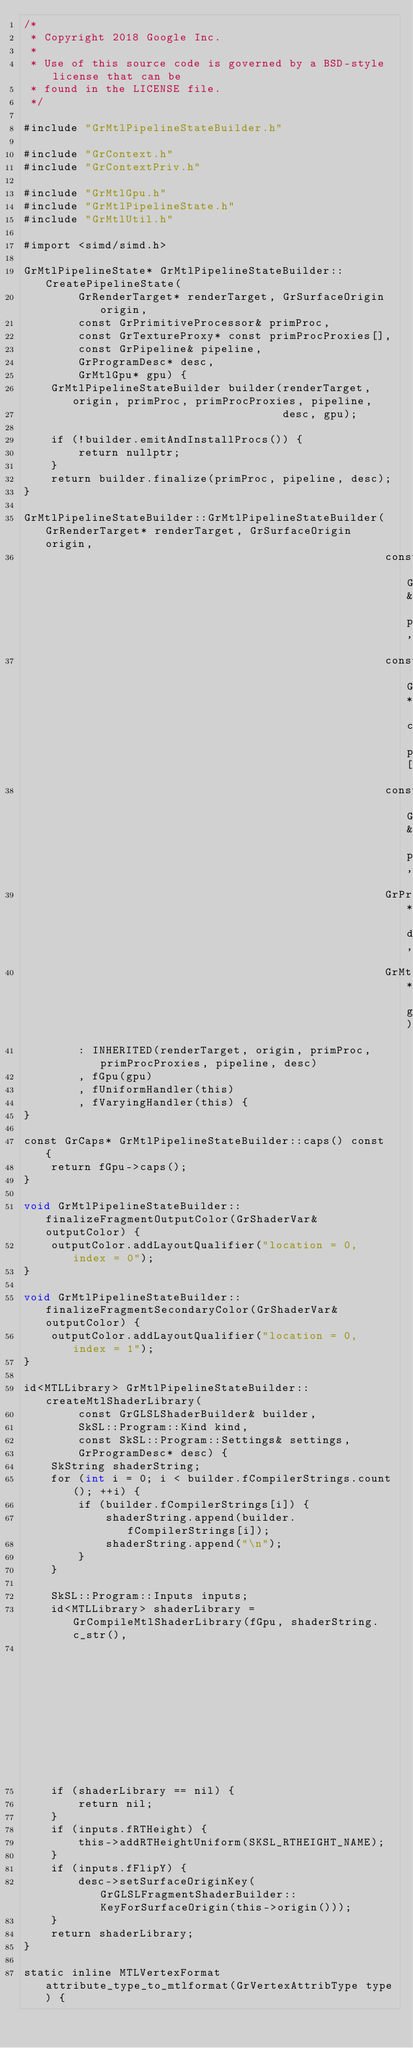Convert code to text. <code><loc_0><loc_0><loc_500><loc_500><_ObjectiveC_>/*
 * Copyright 2018 Google Inc.
 *
 * Use of this source code is governed by a BSD-style license that can be
 * found in the LICENSE file.
 */

#include "GrMtlPipelineStateBuilder.h"

#include "GrContext.h"
#include "GrContextPriv.h"

#include "GrMtlGpu.h"
#include "GrMtlPipelineState.h"
#include "GrMtlUtil.h"

#import <simd/simd.h>

GrMtlPipelineState* GrMtlPipelineStateBuilder::CreatePipelineState(
        GrRenderTarget* renderTarget, GrSurfaceOrigin origin,
        const GrPrimitiveProcessor& primProc,
        const GrTextureProxy* const primProcProxies[],
        const GrPipeline& pipeline,
        GrProgramDesc* desc,
        GrMtlGpu* gpu) {
    GrMtlPipelineStateBuilder builder(renderTarget, origin, primProc, primProcProxies, pipeline,
                                      desc, gpu);

    if (!builder.emitAndInstallProcs()) {
        return nullptr;
    }
    return builder.finalize(primProc, pipeline, desc);
}

GrMtlPipelineStateBuilder::GrMtlPipelineStateBuilder(GrRenderTarget* renderTarget, GrSurfaceOrigin origin,
                                                     const GrPrimitiveProcessor& primProc,
                                                     const GrTextureProxy* const primProcProxies[],
                                                     const GrPipeline& pipeline,
                                                     GrProgramDesc* desc,
                                                     GrMtlGpu* gpu)
        : INHERITED(renderTarget, origin, primProc, primProcProxies, pipeline, desc)
        , fGpu(gpu)
        , fUniformHandler(this)
        , fVaryingHandler(this) {
}

const GrCaps* GrMtlPipelineStateBuilder::caps() const {
    return fGpu->caps();
}

void GrMtlPipelineStateBuilder::finalizeFragmentOutputColor(GrShaderVar& outputColor) {
    outputColor.addLayoutQualifier("location = 0, index = 0");
}

void GrMtlPipelineStateBuilder::finalizeFragmentSecondaryColor(GrShaderVar& outputColor) {
    outputColor.addLayoutQualifier("location = 0, index = 1");
}

id<MTLLibrary> GrMtlPipelineStateBuilder::createMtlShaderLibrary(
        const GrGLSLShaderBuilder& builder,
        SkSL::Program::Kind kind,
        const SkSL::Program::Settings& settings,
        GrProgramDesc* desc) {
    SkString shaderString;
    for (int i = 0; i < builder.fCompilerStrings.count(); ++i) {
        if (builder.fCompilerStrings[i]) {
            shaderString.append(builder.fCompilerStrings[i]);
            shaderString.append("\n");
        }
    }

    SkSL::Program::Inputs inputs;
    id<MTLLibrary> shaderLibrary = GrCompileMtlShaderLibrary(fGpu, shaderString.c_str(),
                                                             kind, settings, &inputs);
    if (shaderLibrary == nil) {
        return nil;
    }
    if (inputs.fRTHeight) {
        this->addRTHeightUniform(SKSL_RTHEIGHT_NAME);
    }
    if (inputs.fFlipY) {
        desc->setSurfaceOriginKey(GrGLSLFragmentShaderBuilder::KeyForSurfaceOrigin(this->origin()));
    }
    return shaderLibrary;
}

static inline MTLVertexFormat attribute_type_to_mtlformat(GrVertexAttribType type) {</code> 